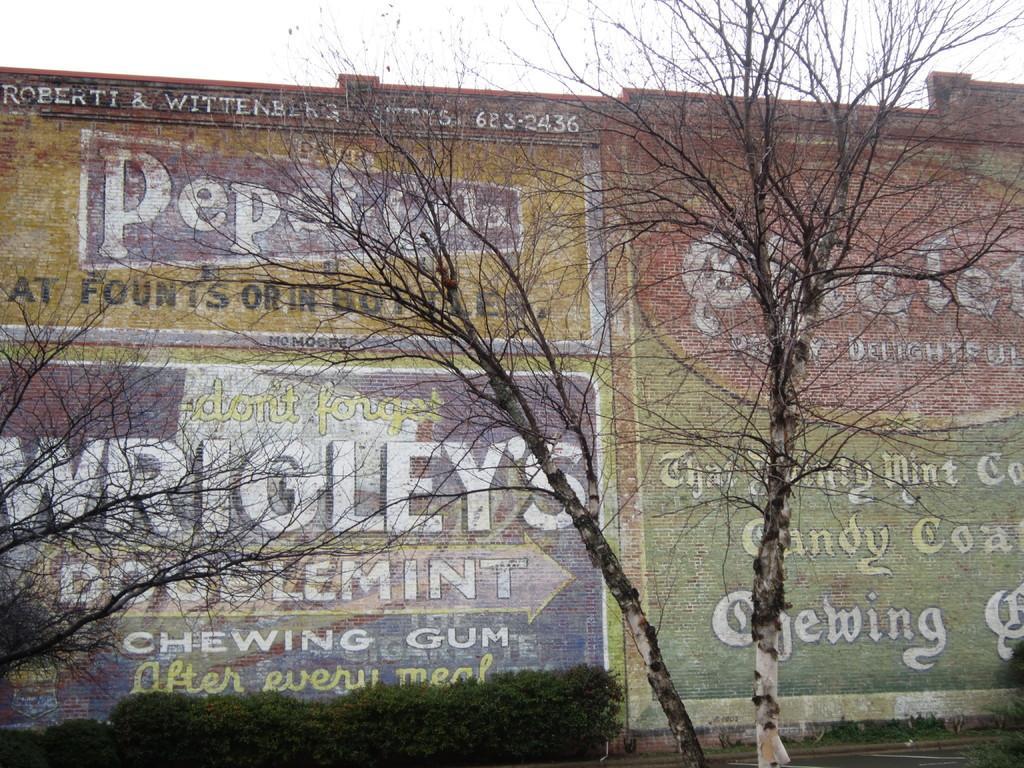In one or two sentences, can you explain what this image depicts? This image is taken outdoors. At the top of the image there is the sky. In the background there is a wall with paintings and there is a text on the wall. In the middle of the image there are two trees and there are a few plants on the ground. 